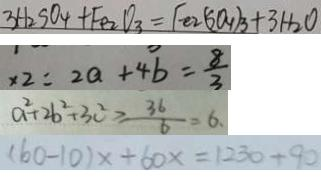Convert formula to latex. <formula><loc_0><loc_0><loc_500><loc_500>3 H _ { 2 } S O _ { 4 } + F e _ { 2 } O _ { 3 } = F e 2 ( S O _ { 4 } ) _ { 3 } + 3 H _ { 2 } O 
 x 2 = 2 a + 4 b = \frac { 8 } { 3 } 
 a ^ { 2 } + 2 b ^ { 2 } + 3 c ^ { 2 } \geq \frac { 3 6 } { 6 } = 6 . 
 ( 6 0 - 1 0 ) x + 6 0 x = 1 2 3 0 + 9 0</formula> 